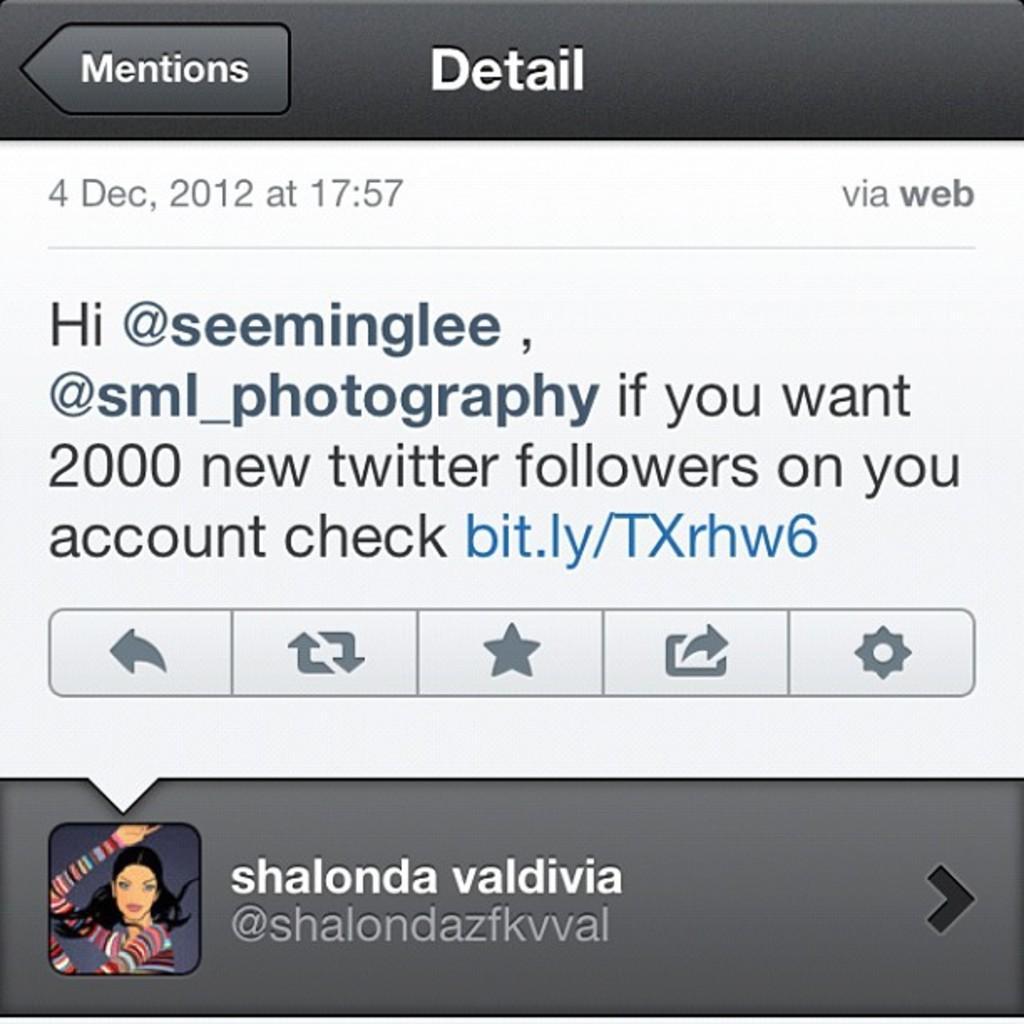How would you summarize this image in a sentence or two? In the image we can see a screen shot, on it there is a text, symbols and profile photo. 